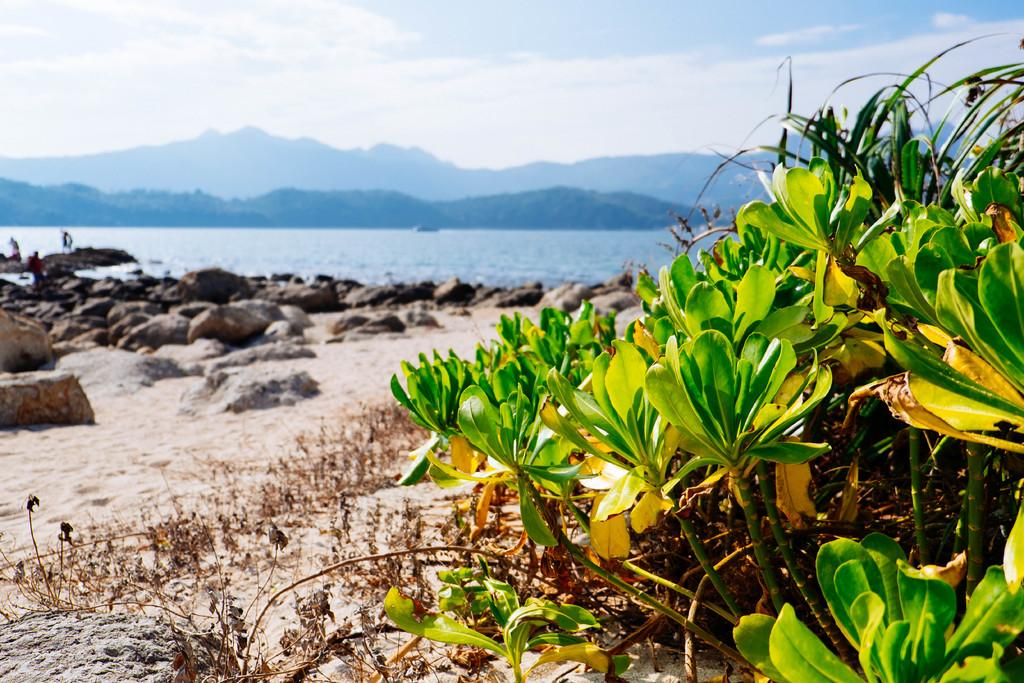What type of natural elements can be seen in the image? There are stones and plants visible in the image. What type of landscape is depicted in the image? There is a beach in the image. What other geographical feature can be seen in the image? There are mountains in the image. What type of work is the mountain doing in the image? The mountain is not performing any work in the image, as mountains are inanimate geographical features. How many times does the sneeze occur in the image? There is no sneezing activity present in the image. 